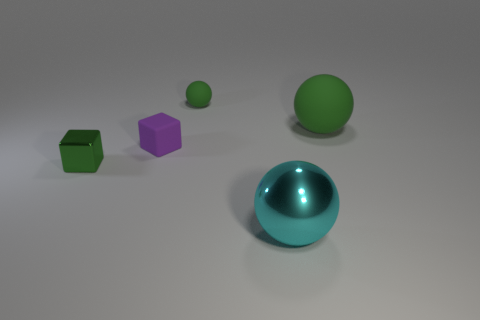Add 1 big rubber balls. How many objects exist? 6 Subtract all cubes. How many objects are left? 3 Subtract all tiny shiny blocks. Subtract all tiny green metal objects. How many objects are left? 3 Add 2 big cyan objects. How many big cyan objects are left? 3 Add 5 tiny blue spheres. How many tiny blue spheres exist? 5 Subtract 0 gray cubes. How many objects are left? 5 